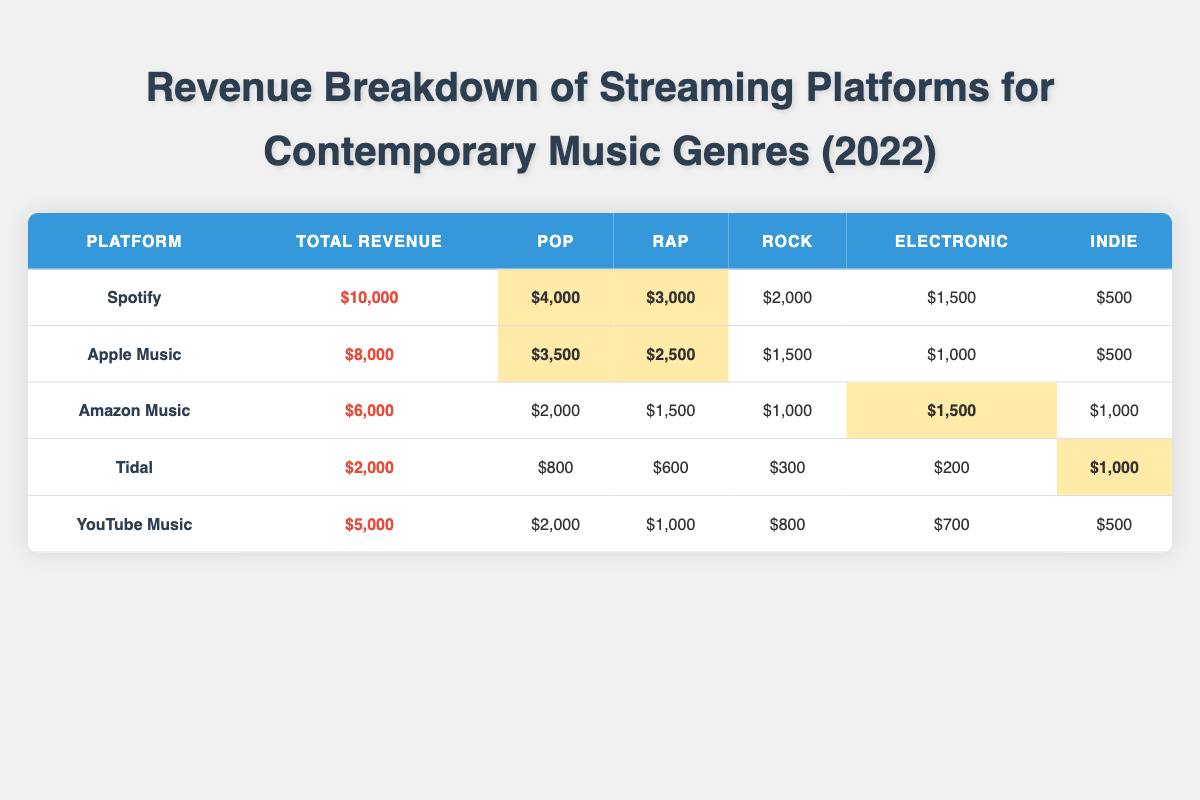What is the total revenue of Spotify? The table shows that the total revenue for Spotify is listed in the "Total Revenue" column which states $10,000.
Answer: $10,000 Which streaming platform has the highest revenue from the rap genre? By comparing the values in the "Rap" column for each platform, Spotify has the highest revenue of $3,000 from the rap genre.
Answer: Spotify What is the revenue breakdown of Tidal for the pop genre? The "Pop" column for Tidal indicates a revenue of $800.
Answer: $800 Which platform generated the least total revenue in 2022? By looking at the "Total Revenue" column, Tidal has the least total revenue of $2,000 among all the platforms.
Answer: Tidal What is the combined revenue from pop for Spotify and Apple Music? The pop revenue for Spotify is $4,000 and for Apple Music, it is $3,500. Adding these values gives $4,000 + $3,500 = $7,500.
Answer: $7,500 What percentage of YouTube Music's total revenue comes from the electronic genre? The total revenue for YouTube Music is $5,000, and the revenue from electronic is $700. The percentage is calculated as ($700 / $5,000) * 100 = 14%.
Answer: 14% Which platform has an equal revenue for the indie genre? Upon examining the "Indie" column, both Apple Music and Amazon Music have an equal revenue of $500 each for the indie genre.
Answer: Apple Music and Amazon Music What is the total revenue from electronic music across all platforms? The electronic revenue for each platform is: Spotify $1,500, Apple Music $1,000, Amazon Music $1,500, Tidal $200, and YouTube Music $700. Summing these gives ($1,500 + $1,000 + $1,500 + $200 + $700) = $5,900.
Answer: $5,900 Which genre generated the highest revenue on Apple Music? In the "breakdown" for Apple Music, the pop genre ($3,500) generated the highest revenue compared to rap ($2,500), rock ($1,500), electronic ($1,000), and indie ($500).
Answer: Pop Is the revenue from indie music on Amazon Music higher than the revenue from rock music? In the table, the indie revenue for Amazon Music is $1,000 and rock revenue is $1,000 as well. Therefore, the indie revenue is equal to the rock revenue.
Answer: No, they are equal 